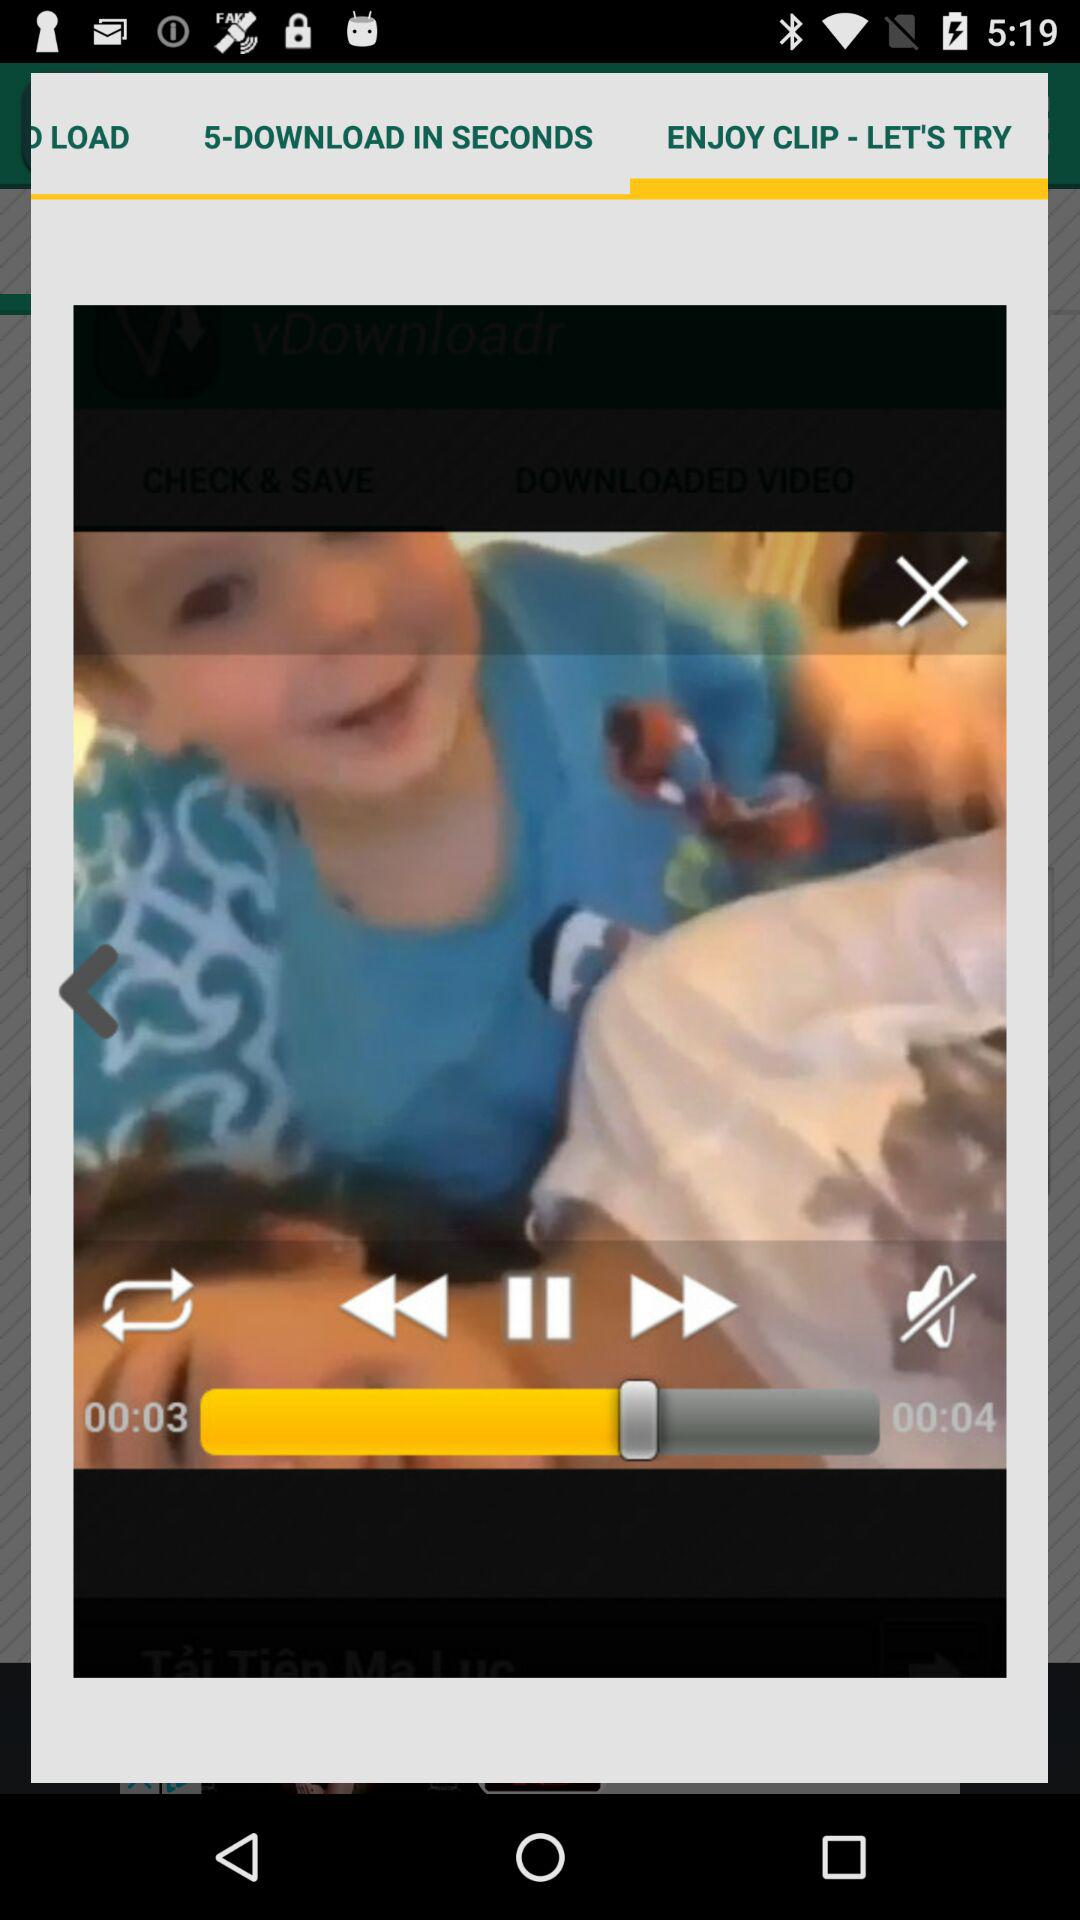How many seconds are between the two timestamps?
Answer the question using a single word or phrase. 1 